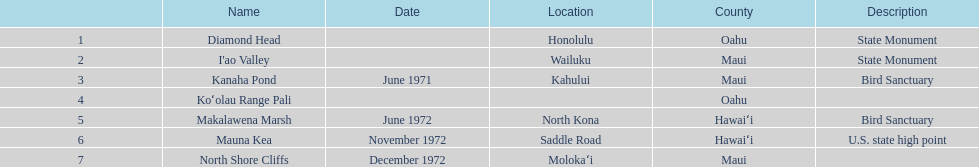What is the number of bird sanctuary landmarks? 2. 